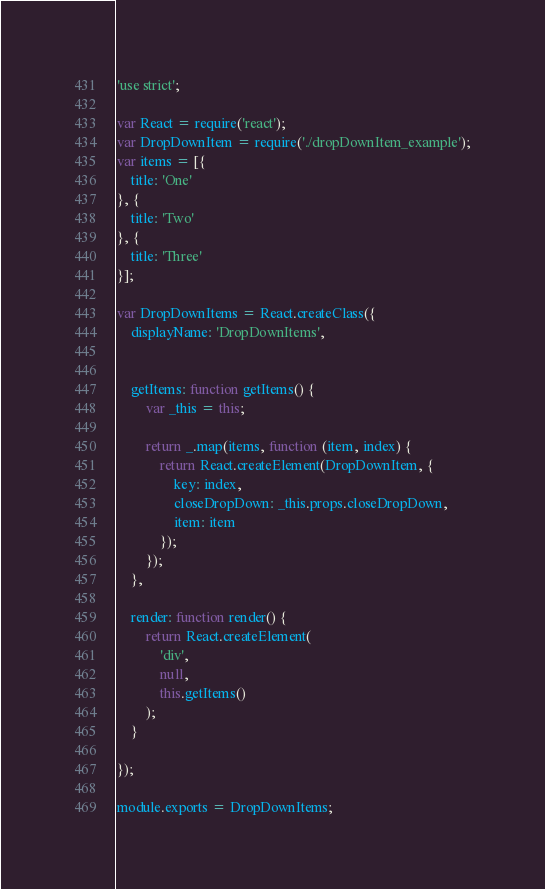Convert code to text. <code><loc_0><loc_0><loc_500><loc_500><_JavaScript_>'use strict';

var React = require('react');
var DropDownItem = require('./dropDownItem_example');
var items = [{
	title: 'One'
}, {
	title: 'Two'
}, {
	title: 'Three'
}];

var DropDownItems = React.createClass({
	displayName: 'DropDownItems',


	getItems: function getItems() {
		var _this = this;

		return _.map(items, function (item, index) {
			return React.createElement(DropDownItem, {
				key: index,
				closeDropDown: _this.props.closeDropDown,
				item: item
			});
		});
	},

	render: function render() {
		return React.createElement(
			'div',
			null,
			this.getItems()
		);
	}

});

module.exports = DropDownItems;</code> 